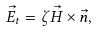<formula> <loc_0><loc_0><loc_500><loc_500>\vec { E } _ { t } = \zeta \vec { H } \times \vec { n } ,</formula> 